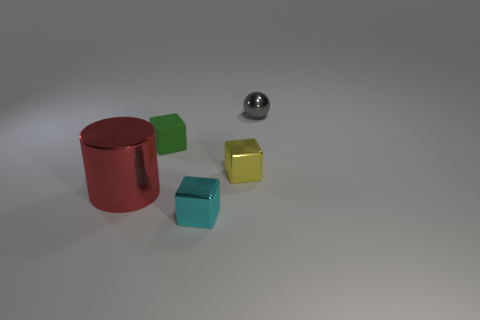Add 2 metallic cylinders. How many objects exist? 7 Subtract all spheres. How many objects are left? 4 Subtract 0 red cubes. How many objects are left? 5 Subtract all tiny cyan shiny cubes. Subtract all tiny cyan blocks. How many objects are left? 3 Add 5 yellow objects. How many yellow objects are left? 6 Add 1 big gray metal cubes. How many big gray metal cubes exist? 1 